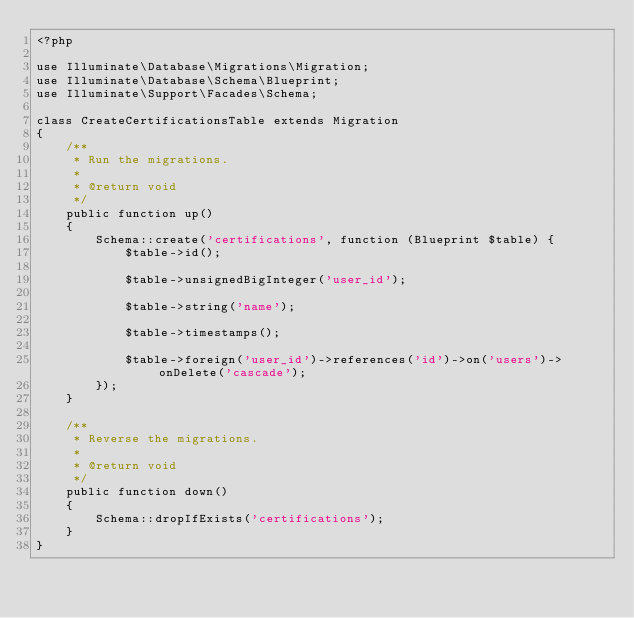<code> <loc_0><loc_0><loc_500><loc_500><_PHP_><?php

use Illuminate\Database\Migrations\Migration;
use Illuminate\Database\Schema\Blueprint;
use Illuminate\Support\Facades\Schema;

class CreateCertificationsTable extends Migration
{
    /**
     * Run the migrations.
     *
     * @return void
     */
    public function up()
    {
        Schema::create('certifications', function (Blueprint $table) {
            $table->id();

            $table->unsignedBigInteger('user_id');

            $table->string('name');

            $table->timestamps();

            $table->foreign('user_id')->references('id')->on('users')->onDelete('cascade');
        });
    }

    /**
     * Reverse the migrations.
     *
     * @return void
     */
    public function down()
    {
        Schema::dropIfExists('certifications');
    }
}
</code> 